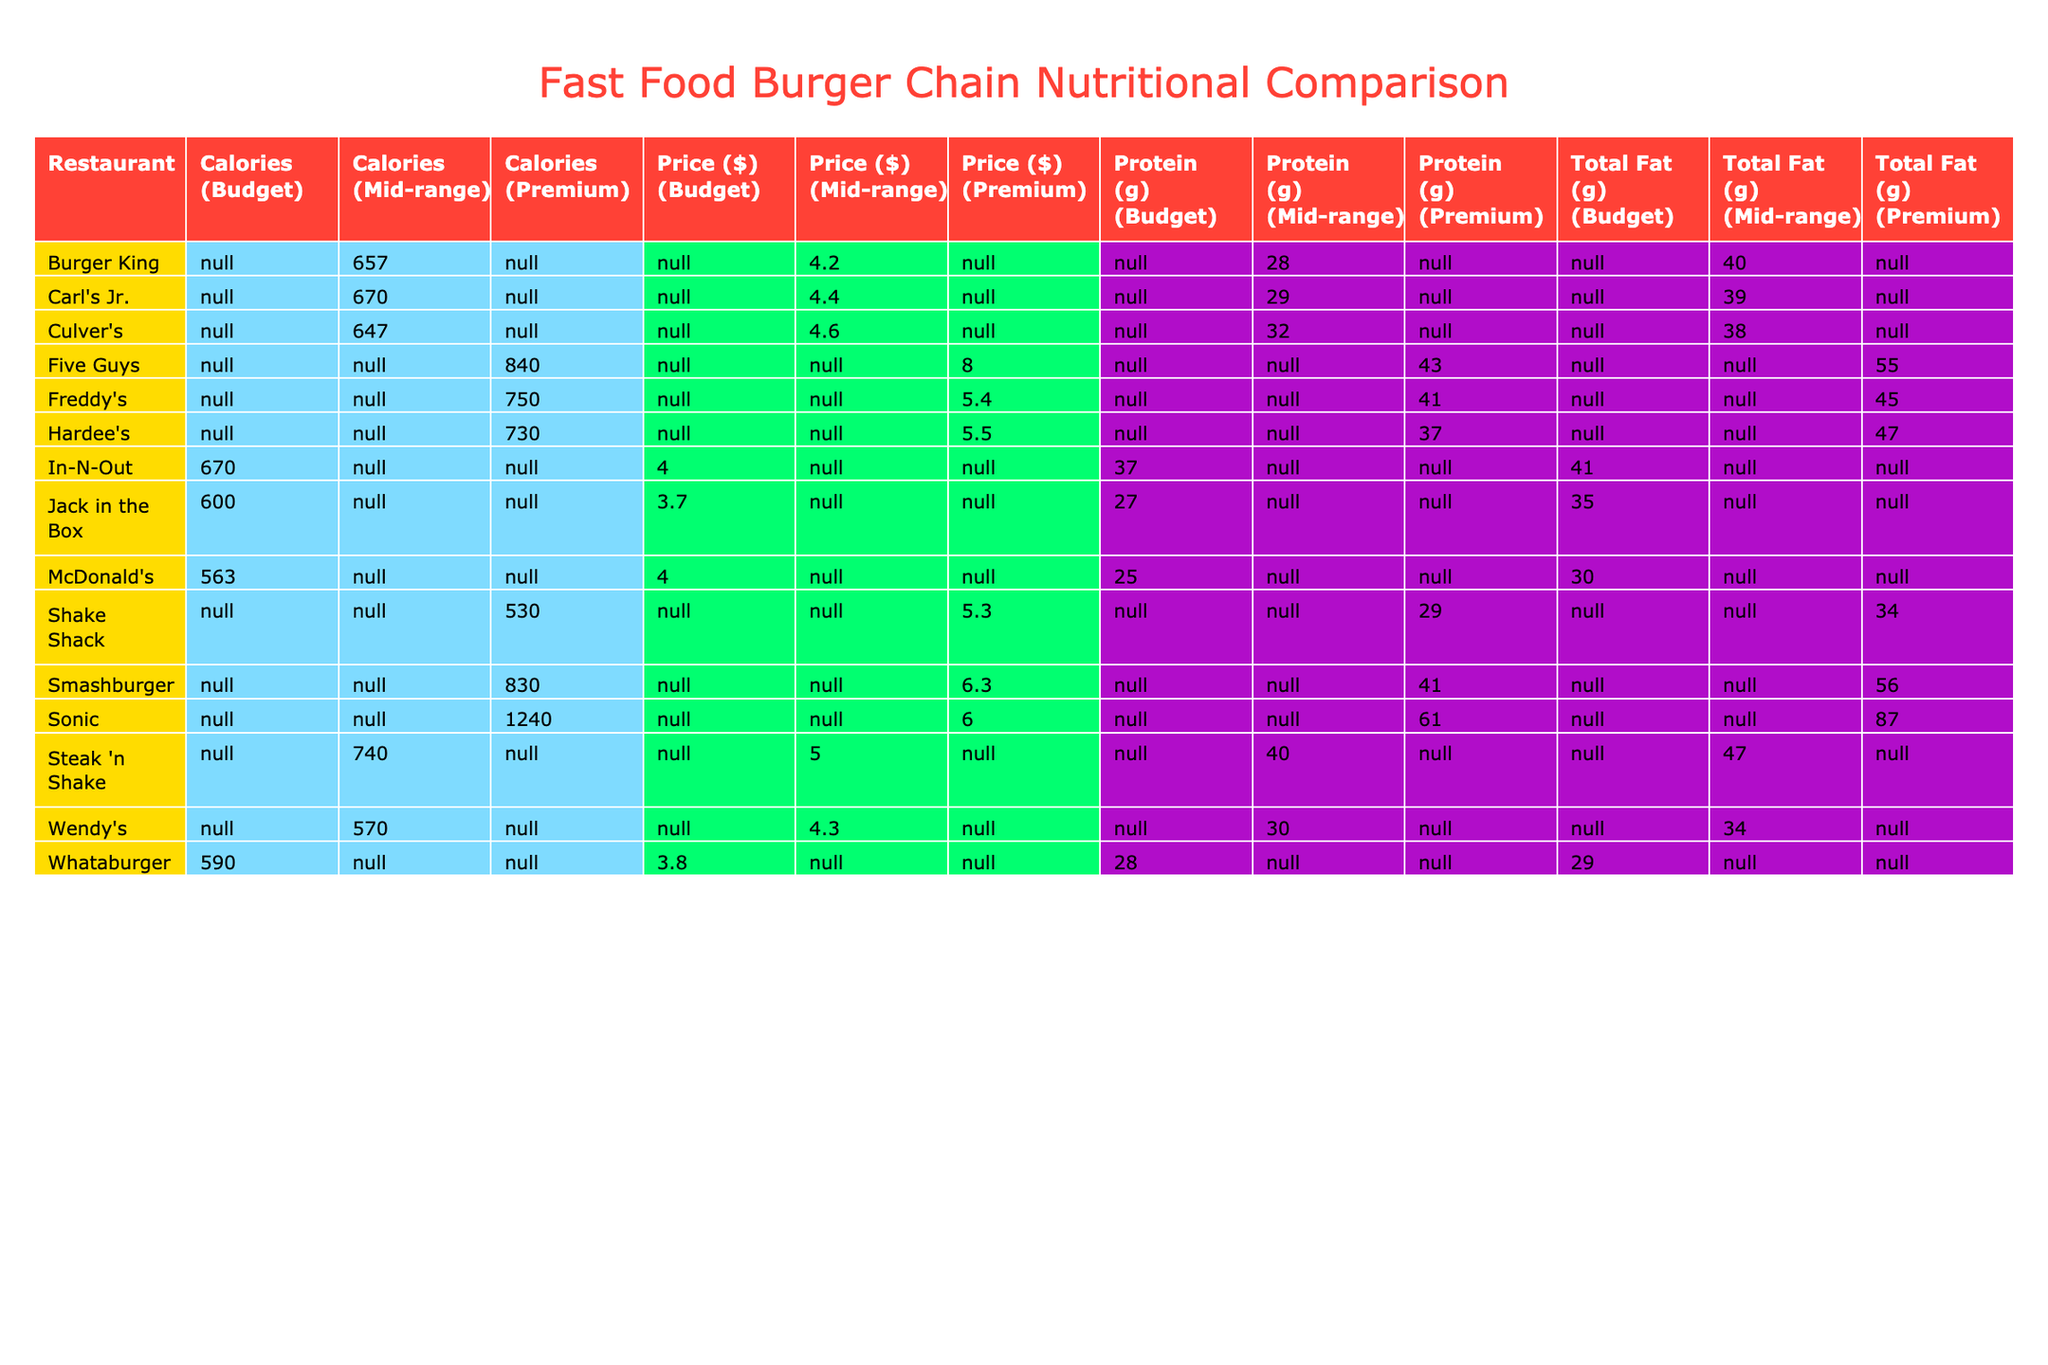What's the highest calorie burger listed in the table? The highest calorie burger is the SuperSONIC Bacon Double Cheeseburger from Sonic, which has 1240 calories.
Answer: 1240 calories Which restaurant has the lowest saturated fat in their burger? The burger with the lowest saturated fat is the Big Mac from McDonald's with 11 grams of saturated fat.
Answer: 11 grams What is the average calorie count for the burgers in the Mid-range price category? The burgers in the Mid-range category are Wendy's Dave's Single (570), Carl's Jr. Famous Star with Cheese (670), In-N-Out Double-Double (670), and Culver's ButterBurger Cheese (647). Adding these gives 570 + 670 + 670 + 647 = 2557. Dividing by 4 gives an average of 639.25.
Answer: 639.3 Does Five Guys have a burger with more protein than Hardee's Thickburger? Five Guys Cheeseburger has 43 grams of protein, while Hardee’s Thickburger has 37 grams. Hence, Five Guys has more protein than Hardee’s Thickburger.
Answer: Yes What is the difference in total fat between the Whopper and the Shake Shack ShackBurger? The Whopper has 40 grams of total fat while the ShackBurger has 34 grams. The difference is 40 - 34 = 6 grams.
Answer: 6 grams Which burger has the highest sodium content, and what is its value? The burger with the highest sodium content is the SuperSONIC Bacon Double Cheeseburger from Sonic, with 1690 mg of sodium.
Answer: 1690 mg Which restaurant has a burger priced in the budget category but has more calories than the Double-Double? The Whataburger from Whataburger is priced at $3.79 and has 590 calories, which is more than the 670 calories of the In-N-Out Double-Double.
Answer: Whataburger Calculate the average price of burgers in the Premium category. The Premium category includes Five Guys Cheeseburger ($7.99) and Smashburger Classic Smash ($6.29). Adding these gives $7.99 + $6.29 = $14.28. Dividing by 2 gives an average of $7.14.
Answer: $7.14 